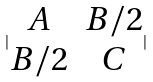Convert formula to latex. <formula><loc_0><loc_0><loc_500><loc_500>| \begin{matrix} A & B / 2 \\ B / 2 & C \end{matrix} |</formula> 